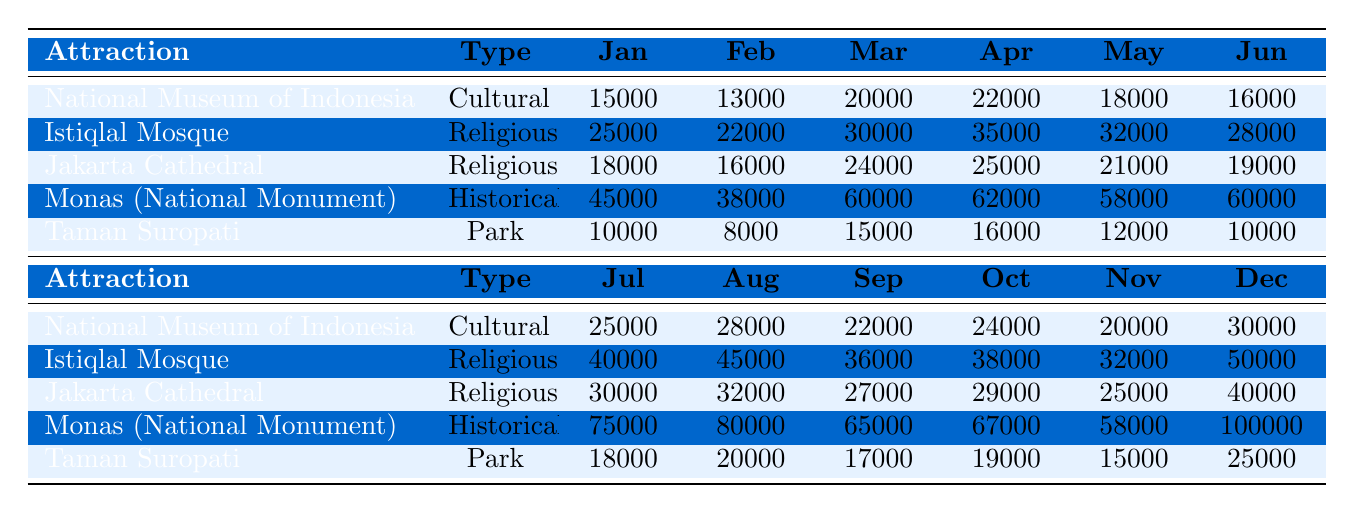What is the total number of visitors to the Istiqlal Mosque in August? From the table, I can see that the monthly visitors for the Istiqlal Mosque in August is 45000.
Answer: 45000 Which attraction had the highest number of visitors in December? The highest number of visitors in December can be found by comparing the values for each attraction. Monas (National Monument) had 100000 visitors in December, which is the highest number.
Answer: Monas (National Monument) What was the average number of visitors to the Jakarta Cathedral from January to June? To calculate the average, I sum the visited numbers from January (18000), February (16000), March (24000), April (25000), May (21000), and June (19000), getting a total of 115000. Then, I divide by the 6 months: 115000 / 6 = 19166.67.
Answer: Approximately 19167 Did Taman Suropati have more visitors in November than in January? Looking at the table, Taman Suropati had 15000 visitors in November and 10000 in January. Since 15000 is greater than 10000, the statement is true.
Answer: Yes Which attraction had a decline in visitors from March to April, and what was the decline amount? I compare the visitor numbers for each attraction between March (various values) and April. Only the Jakarta Cathedral declined from 24000 in March to 25000 in April, which is an increase, but others had other results. I check for more: National Museum increased from 20000 to 22000, Istiqlal from 30000 to 35000, Monas from 60000 to 62000, Taman Suropati from 15000 to 16000. It seems none showed a decline.
Answer: None What is the difference in visitors between the Monas and the National Museum in October? I find the visitor numbers in October: Monas had 67000 visitors and the National Museum had 24000 visitors. To find the difference, I subtract the National Museum count from Monas: 67000 - 24000 = 43000.
Answer: 43000 